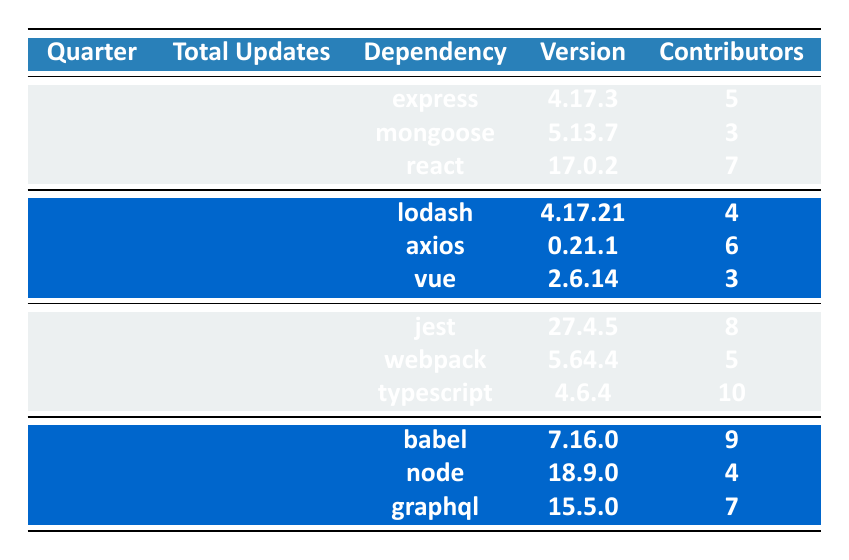What is the total number of updates in Q2 2023? In Q2 2023, the table states that there were 10 total updates listed under that quarter.
Answer: 10 Which dependency had the highest number of contributors in Q3 2023? In Q3 2023, the dependencies are jest (8 contributors), webpack (5 contributors), and typescript (10 contributors). Typescript has the highest number of contributors at 10.
Answer: typescript What is the average number of contributors across all quarters? To find the average, sum the total contributors for all dependencies across all quarters: (5 + 3 + 7 + 4 + 6 + 3 + 8 + 5 + 10 + 9 + 4 + 7) = 71. Then divide by the number of updates, which is 45 (12 + 10 + 8 + 15). 71 divided by 45 equals approximately 1.58.
Answer: 1.58 Was there a dependency updated in Q4 2023 that had more contributors than any dependency updated in Q1 2023? In Q4 2023, babel had 9 contributors, which is higher than all dependencies in Q1 2023 (express: 5, mongoose: 3, react: 7). Thus, the answer is yes.
Answer: Yes How many total updates were there from Q1 to Q3 2023? The total updates from Q1 to Q3 2023 are calculated by adding the total updates in each quarter: Q1 (12) + Q2 (10) + Q3 (8) = 30.
Answer: 30 Which quarter had more updates, Q1 or Q4 2023? Q1 2023 had 12 updates while Q4 2023 had 15 updates. Comparing these numbers, Q4 has more updates than Q1.
Answer: Q4 2023 What was the release date of the dependency with the maximum number of contributors in Q2 2023? In Q2 2023, axios has the highest number of contributors at 6, and it was released on 2023-04-12.
Answer: 2023-04-12 Which quarter had the least total updates? The total updates for each quarter are Q1 (12), Q2 (10), Q3 (8), and Q4 (15). Q3 has the least total updates at 8.
Answer: Q3 2023 